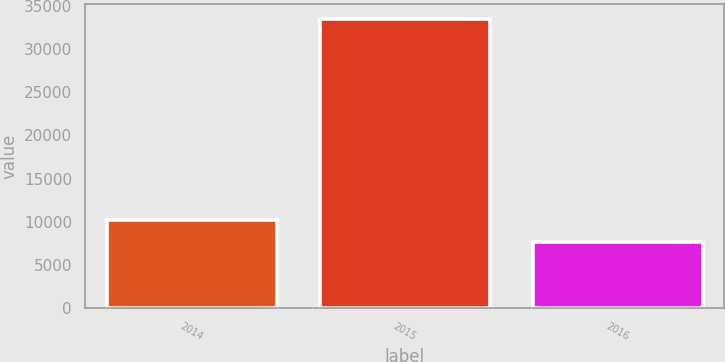Convert chart to OTSL. <chart><loc_0><loc_0><loc_500><loc_500><bar_chart><fcel>2014<fcel>2015<fcel>2016<nl><fcel>10244.9<fcel>33509<fcel>7660<nl></chart> 